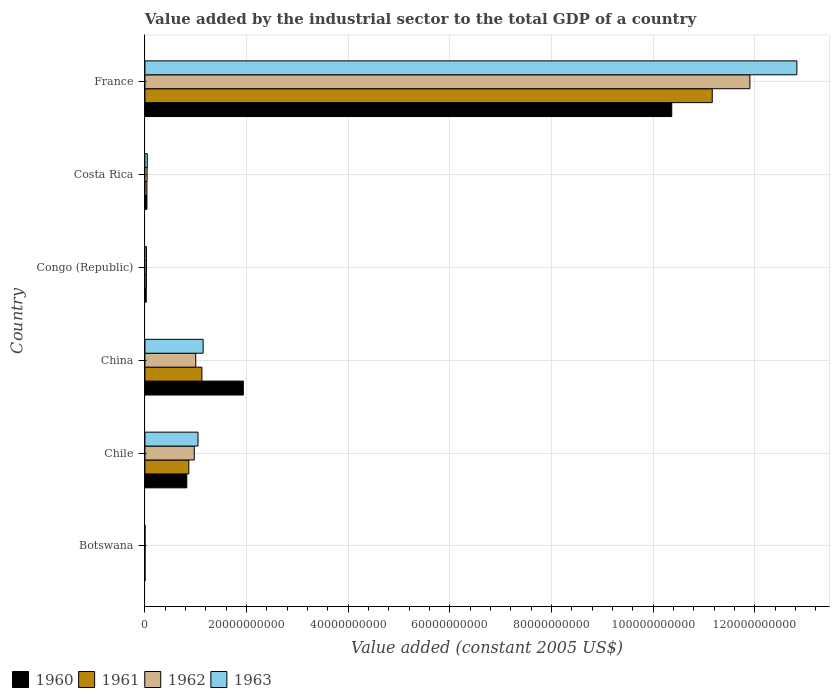How many different coloured bars are there?
Ensure brevity in your answer.  4. Are the number of bars per tick equal to the number of legend labels?
Make the answer very short. Yes. How many bars are there on the 5th tick from the top?
Make the answer very short. 4. How many bars are there on the 5th tick from the bottom?
Give a very brief answer. 4. In how many cases, is the number of bars for a given country not equal to the number of legend labels?
Your answer should be very brief. 0. What is the value added by the industrial sector in 1960 in Costa Rica?
Offer a terse response. 3.98e+08. Across all countries, what is the maximum value added by the industrial sector in 1962?
Provide a succinct answer. 1.19e+11. Across all countries, what is the minimum value added by the industrial sector in 1962?
Your answer should be very brief. 1.98e+07. In which country was the value added by the industrial sector in 1960 minimum?
Make the answer very short. Botswana. What is the total value added by the industrial sector in 1960 in the graph?
Make the answer very short. 1.32e+11. What is the difference between the value added by the industrial sector in 1960 in Congo (Republic) and that in France?
Make the answer very short. -1.03e+11. What is the difference between the value added by the industrial sector in 1961 in Botswana and the value added by the industrial sector in 1963 in China?
Your answer should be very brief. -1.14e+1. What is the average value added by the industrial sector in 1963 per country?
Make the answer very short. 2.52e+1. What is the difference between the value added by the industrial sector in 1962 and value added by the industrial sector in 1960 in Chile?
Your response must be concise. 1.47e+09. What is the ratio of the value added by the industrial sector in 1961 in Chile to that in France?
Give a very brief answer. 0.08. Is the value added by the industrial sector in 1961 in Costa Rica less than that in France?
Ensure brevity in your answer.  Yes. What is the difference between the highest and the second highest value added by the industrial sector in 1961?
Your answer should be very brief. 1.00e+11. What is the difference between the highest and the lowest value added by the industrial sector in 1962?
Ensure brevity in your answer.  1.19e+11. In how many countries, is the value added by the industrial sector in 1960 greater than the average value added by the industrial sector in 1960 taken over all countries?
Your answer should be compact. 1. Is the sum of the value added by the industrial sector in 1963 in Congo (Republic) and France greater than the maximum value added by the industrial sector in 1961 across all countries?
Your response must be concise. Yes. Is it the case that in every country, the sum of the value added by the industrial sector in 1961 and value added by the industrial sector in 1963 is greater than the sum of value added by the industrial sector in 1960 and value added by the industrial sector in 1962?
Offer a very short reply. No. Is it the case that in every country, the sum of the value added by the industrial sector in 1960 and value added by the industrial sector in 1962 is greater than the value added by the industrial sector in 1963?
Your answer should be compact. Yes. Are the values on the major ticks of X-axis written in scientific E-notation?
Offer a terse response. No. How many legend labels are there?
Your answer should be compact. 4. How are the legend labels stacked?
Ensure brevity in your answer.  Horizontal. What is the title of the graph?
Keep it short and to the point. Value added by the industrial sector to the total GDP of a country. What is the label or title of the X-axis?
Provide a succinct answer. Value added (constant 2005 US$). What is the label or title of the Y-axis?
Offer a terse response. Country. What is the Value added (constant 2005 US$) of 1960 in Botswana?
Your answer should be compact. 1.96e+07. What is the Value added (constant 2005 US$) of 1961 in Botswana?
Ensure brevity in your answer.  1.92e+07. What is the Value added (constant 2005 US$) in 1962 in Botswana?
Make the answer very short. 1.98e+07. What is the Value added (constant 2005 US$) in 1963 in Botswana?
Keep it short and to the point. 1.83e+07. What is the Value added (constant 2005 US$) of 1960 in Chile?
Provide a short and direct response. 8.24e+09. What is the Value added (constant 2005 US$) in 1961 in Chile?
Provide a succinct answer. 8.64e+09. What is the Value added (constant 2005 US$) in 1962 in Chile?
Make the answer very short. 9.71e+09. What is the Value added (constant 2005 US$) of 1963 in Chile?
Make the answer very short. 1.04e+1. What is the Value added (constant 2005 US$) in 1960 in China?
Give a very brief answer. 1.94e+1. What is the Value added (constant 2005 US$) in 1961 in China?
Offer a terse response. 1.12e+1. What is the Value added (constant 2005 US$) of 1962 in China?
Give a very brief answer. 1.00e+1. What is the Value added (constant 2005 US$) in 1963 in China?
Your answer should be compact. 1.15e+1. What is the Value added (constant 2005 US$) of 1960 in Congo (Republic)?
Provide a short and direct response. 2.61e+08. What is the Value added (constant 2005 US$) of 1961 in Congo (Republic)?
Your response must be concise. 2.98e+08. What is the Value added (constant 2005 US$) in 1962 in Congo (Republic)?
Give a very brief answer. 3.12e+08. What is the Value added (constant 2005 US$) of 1963 in Congo (Republic)?
Provide a succinct answer. 3.00e+08. What is the Value added (constant 2005 US$) of 1960 in Costa Rica?
Give a very brief answer. 3.98e+08. What is the Value added (constant 2005 US$) in 1961 in Costa Rica?
Your response must be concise. 3.94e+08. What is the Value added (constant 2005 US$) in 1962 in Costa Rica?
Provide a short and direct response. 4.27e+08. What is the Value added (constant 2005 US$) in 1963 in Costa Rica?
Ensure brevity in your answer.  4.68e+08. What is the Value added (constant 2005 US$) of 1960 in France?
Offer a terse response. 1.04e+11. What is the Value added (constant 2005 US$) in 1961 in France?
Offer a terse response. 1.12e+11. What is the Value added (constant 2005 US$) in 1962 in France?
Ensure brevity in your answer.  1.19e+11. What is the Value added (constant 2005 US$) of 1963 in France?
Provide a succinct answer. 1.28e+11. Across all countries, what is the maximum Value added (constant 2005 US$) in 1960?
Offer a terse response. 1.04e+11. Across all countries, what is the maximum Value added (constant 2005 US$) of 1961?
Your response must be concise. 1.12e+11. Across all countries, what is the maximum Value added (constant 2005 US$) of 1962?
Your answer should be very brief. 1.19e+11. Across all countries, what is the maximum Value added (constant 2005 US$) in 1963?
Keep it short and to the point. 1.28e+11. Across all countries, what is the minimum Value added (constant 2005 US$) of 1960?
Your response must be concise. 1.96e+07. Across all countries, what is the minimum Value added (constant 2005 US$) in 1961?
Ensure brevity in your answer.  1.92e+07. Across all countries, what is the minimum Value added (constant 2005 US$) of 1962?
Your response must be concise. 1.98e+07. Across all countries, what is the minimum Value added (constant 2005 US$) of 1963?
Keep it short and to the point. 1.83e+07. What is the total Value added (constant 2005 US$) in 1960 in the graph?
Ensure brevity in your answer.  1.32e+11. What is the total Value added (constant 2005 US$) of 1961 in the graph?
Your answer should be very brief. 1.32e+11. What is the total Value added (constant 2005 US$) in 1962 in the graph?
Keep it short and to the point. 1.40e+11. What is the total Value added (constant 2005 US$) in 1963 in the graph?
Provide a succinct answer. 1.51e+11. What is the difference between the Value added (constant 2005 US$) of 1960 in Botswana and that in Chile?
Provide a short and direct response. -8.22e+09. What is the difference between the Value added (constant 2005 US$) of 1961 in Botswana and that in Chile?
Keep it short and to the point. -8.62e+09. What is the difference between the Value added (constant 2005 US$) of 1962 in Botswana and that in Chile?
Provide a succinct answer. -9.69e+09. What is the difference between the Value added (constant 2005 US$) of 1963 in Botswana and that in Chile?
Your response must be concise. -1.04e+1. What is the difference between the Value added (constant 2005 US$) in 1960 in Botswana and that in China?
Your response must be concise. -1.93e+1. What is the difference between the Value added (constant 2005 US$) in 1961 in Botswana and that in China?
Your response must be concise. -1.12e+1. What is the difference between the Value added (constant 2005 US$) in 1962 in Botswana and that in China?
Make the answer very short. -9.98e+09. What is the difference between the Value added (constant 2005 US$) in 1963 in Botswana and that in China?
Offer a very short reply. -1.14e+1. What is the difference between the Value added (constant 2005 US$) in 1960 in Botswana and that in Congo (Republic)?
Ensure brevity in your answer.  -2.42e+08. What is the difference between the Value added (constant 2005 US$) of 1961 in Botswana and that in Congo (Republic)?
Your answer should be compact. -2.78e+08. What is the difference between the Value added (constant 2005 US$) in 1962 in Botswana and that in Congo (Republic)?
Provide a short and direct response. -2.93e+08. What is the difference between the Value added (constant 2005 US$) in 1963 in Botswana and that in Congo (Republic)?
Your answer should be compact. -2.81e+08. What is the difference between the Value added (constant 2005 US$) of 1960 in Botswana and that in Costa Rica?
Your answer should be very brief. -3.78e+08. What is the difference between the Value added (constant 2005 US$) in 1961 in Botswana and that in Costa Rica?
Keep it short and to the point. -3.74e+08. What is the difference between the Value added (constant 2005 US$) in 1962 in Botswana and that in Costa Rica?
Make the answer very short. -4.07e+08. What is the difference between the Value added (constant 2005 US$) in 1963 in Botswana and that in Costa Rica?
Offer a terse response. -4.50e+08. What is the difference between the Value added (constant 2005 US$) of 1960 in Botswana and that in France?
Provide a short and direct response. -1.04e+11. What is the difference between the Value added (constant 2005 US$) in 1961 in Botswana and that in France?
Your response must be concise. -1.12e+11. What is the difference between the Value added (constant 2005 US$) in 1962 in Botswana and that in France?
Ensure brevity in your answer.  -1.19e+11. What is the difference between the Value added (constant 2005 US$) in 1963 in Botswana and that in France?
Ensure brevity in your answer.  -1.28e+11. What is the difference between the Value added (constant 2005 US$) of 1960 in Chile and that in China?
Your answer should be very brief. -1.11e+1. What is the difference between the Value added (constant 2005 US$) in 1961 in Chile and that in China?
Offer a very short reply. -2.57e+09. What is the difference between the Value added (constant 2005 US$) in 1962 in Chile and that in China?
Ensure brevity in your answer.  -2.92e+08. What is the difference between the Value added (constant 2005 US$) of 1963 in Chile and that in China?
Offer a very short reply. -1.01e+09. What is the difference between the Value added (constant 2005 US$) in 1960 in Chile and that in Congo (Republic)?
Your answer should be very brief. 7.98e+09. What is the difference between the Value added (constant 2005 US$) of 1961 in Chile and that in Congo (Republic)?
Make the answer very short. 8.34e+09. What is the difference between the Value added (constant 2005 US$) in 1962 in Chile and that in Congo (Republic)?
Offer a terse response. 9.40e+09. What is the difference between the Value added (constant 2005 US$) in 1963 in Chile and that in Congo (Republic)?
Your answer should be very brief. 1.01e+1. What is the difference between the Value added (constant 2005 US$) of 1960 in Chile and that in Costa Rica?
Offer a terse response. 7.84e+09. What is the difference between the Value added (constant 2005 US$) of 1961 in Chile and that in Costa Rica?
Offer a very short reply. 8.25e+09. What is the difference between the Value added (constant 2005 US$) in 1962 in Chile and that in Costa Rica?
Offer a very short reply. 9.28e+09. What is the difference between the Value added (constant 2005 US$) in 1963 in Chile and that in Costa Rica?
Your answer should be compact. 9.98e+09. What is the difference between the Value added (constant 2005 US$) of 1960 in Chile and that in France?
Provide a short and direct response. -9.54e+1. What is the difference between the Value added (constant 2005 US$) in 1961 in Chile and that in France?
Your answer should be compact. -1.03e+11. What is the difference between the Value added (constant 2005 US$) of 1962 in Chile and that in France?
Your answer should be very brief. -1.09e+11. What is the difference between the Value added (constant 2005 US$) of 1963 in Chile and that in France?
Your response must be concise. -1.18e+11. What is the difference between the Value added (constant 2005 US$) of 1960 in China and that in Congo (Republic)?
Your answer should be compact. 1.91e+1. What is the difference between the Value added (constant 2005 US$) in 1961 in China and that in Congo (Republic)?
Provide a succinct answer. 1.09e+1. What is the difference between the Value added (constant 2005 US$) of 1962 in China and that in Congo (Republic)?
Provide a short and direct response. 9.69e+09. What is the difference between the Value added (constant 2005 US$) of 1963 in China and that in Congo (Republic)?
Provide a succinct answer. 1.12e+1. What is the difference between the Value added (constant 2005 US$) in 1960 in China and that in Costa Rica?
Make the answer very short. 1.90e+1. What is the difference between the Value added (constant 2005 US$) of 1961 in China and that in Costa Rica?
Your response must be concise. 1.08e+1. What is the difference between the Value added (constant 2005 US$) of 1962 in China and that in Costa Rica?
Your answer should be very brief. 9.58e+09. What is the difference between the Value added (constant 2005 US$) of 1963 in China and that in Costa Rica?
Ensure brevity in your answer.  1.10e+1. What is the difference between the Value added (constant 2005 US$) in 1960 in China and that in France?
Your answer should be compact. -8.43e+1. What is the difference between the Value added (constant 2005 US$) in 1961 in China and that in France?
Keep it short and to the point. -1.00e+11. What is the difference between the Value added (constant 2005 US$) in 1962 in China and that in France?
Your response must be concise. -1.09e+11. What is the difference between the Value added (constant 2005 US$) in 1963 in China and that in France?
Keep it short and to the point. -1.17e+11. What is the difference between the Value added (constant 2005 US$) of 1960 in Congo (Republic) and that in Costa Rica?
Offer a very short reply. -1.36e+08. What is the difference between the Value added (constant 2005 US$) of 1961 in Congo (Republic) and that in Costa Rica?
Offer a very short reply. -9.59e+07. What is the difference between the Value added (constant 2005 US$) of 1962 in Congo (Republic) and that in Costa Rica?
Keep it short and to the point. -1.14e+08. What is the difference between the Value added (constant 2005 US$) in 1963 in Congo (Republic) and that in Costa Rica?
Your answer should be compact. -1.68e+08. What is the difference between the Value added (constant 2005 US$) in 1960 in Congo (Republic) and that in France?
Provide a short and direct response. -1.03e+11. What is the difference between the Value added (constant 2005 US$) in 1961 in Congo (Republic) and that in France?
Offer a very short reply. -1.11e+11. What is the difference between the Value added (constant 2005 US$) in 1962 in Congo (Republic) and that in France?
Your answer should be very brief. -1.19e+11. What is the difference between the Value added (constant 2005 US$) of 1963 in Congo (Republic) and that in France?
Your answer should be very brief. -1.28e+11. What is the difference between the Value added (constant 2005 US$) in 1960 in Costa Rica and that in France?
Your answer should be compact. -1.03e+11. What is the difference between the Value added (constant 2005 US$) of 1961 in Costa Rica and that in France?
Give a very brief answer. -1.11e+11. What is the difference between the Value added (constant 2005 US$) of 1962 in Costa Rica and that in France?
Keep it short and to the point. -1.19e+11. What is the difference between the Value added (constant 2005 US$) of 1963 in Costa Rica and that in France?
Make the answer very short. -1.28e+11. What is the difference between the Value added (constant 2005 US$) in 1960 in Botswana and the Value added (constant 2005 US$) in 1961 in Chile?
Keep it short and to the point. -8.62e+09. What is the difference between the Value added (constant 2005 US$) of 1960 in Botswana and the Value added (constant 2005 US$) of 1962 in Chile?
Ensure brevity in your answer.  -9.69e+09. What is the difference between the Value added (constant 2005 US$) in 1960 in Botswana and the Value added (constant 2005 US$) in 1963 in Chile?
Keep it short and to the point. -1.04e+1. What is the difference between the Value added (constant 2005 US$) of 1961 in Botswana and the Value added (constant 2005 US$) of 1962 in Chile?
Ensure brevity in your answer.  -9.69e+09. What is the difference between the Value added (constant 2005 US$) in 1961 in Botswana and the Value added (constant 2005 US$) in 1963 in Chile?
Offer a very short reply. -1.04e+1. What is the difference between the Value added (constant 2005 US$) in 1962 in Botswana and the Value added (constant 2005 US$) in 1963 in Chile?
Give a very brief answer. -1.04e+1. What is the difference between the Value added (constant 2005 US$) of 1960 in Botswana and the Value added (constant 2005 US$) of 1961 in China?
Give a very brief answer. -1.12e+1. What is the difference between the Value added (constant 2005 US$) of 1960 in Botswana and the Value added (constant 2005 US$) of 1962 in China?
Your response must be concise. -9.98e+09. What is the difference between the Value added (constant 2005 US$) in 1960 in Botswana and the Value added (constant 2005 US$) in 1963 in China?
Offer a very short reply. -1.14e+1. What is the difference between the Value added (constant 2005 US$) in 1961 in Botswana and the Value added (constant 2005 US$) in 1962 in China?
Keep it short and to the point. -9.98e+09. What is the difference between the Value added (constant 2005 US$) of 1961 in Botswana and the Value added (constant 2005 US$) of 1963 in China?
Ensure brevity in your answer.  -1.14e+1. What is the difference between the Value added (constant 2005 US$) of 1962 in Botswana and the Value added (constant 2005 US$) of 1963 in China?
Your answer should be very brief. -1.14e+1. What is the difference between the Value added (constant 2005 US$) of 1960 in Botswana and the Value added (constant 2005 US$) of 1961 in Congo (Republic)?
Make the answer very short. -2.78e+08. What is the difference between the Value added (constant 2005 US$) in 1960 in Botswana and the Value added (constant 2005 US$) in 1962 in Congo (Republic)?
Provide a short and direct response. -2.93e+08. What is the difference between the Value added (constant 2005 US$) of 1960 in Botswana and the Value added (constant 2005 US$) of 1963 in Congo (Republic)?
Keep it short and to the point. -2.80e+08. What is the difference between the Value added (constant 2005 US$) in 1961 in Botswana and the Value added (constant 2005 US$) in 1962 in Congo (Republic)?
Your answer should be compact. -2.93e+08. What is the difference between the Value added (constant 2005 US$) in 1961 in Botswana and the Value added (constant 2005 US$) in 1963 in Congo (Republic)?
Your response must be concise. -2.81e+08. What is the difference between the Value added (constant 2005 US$) of 1962 in Botswana and the Value added (constant 2005 US$) of 1963 in Congo (Republic)?
Your answer should be compact. -2.80e+08. What is the difference between the Value added (constant 2005 US$) of 1960 in Botswana and the Value added (constant 2005 US$) of 1961 in Costa Rica?
Your answer should be compact. -3.74e+08. What is the difference between the Value added (constant 2005 US$) of 1960 in Botswana and the Value added (constant 2005 US$) of 1962 in Costa Rica?
Provide a short and direct response. -4.07e+08. What is the difference between the Value added (constant 2005 US$) of 1960 in Botswana and the Value added (constant 2005 US$) of 1963 in Costa Rica?
Make the answer very short. -4.48e+08. What is the difference between the Value added (constant 2005 US$) of 1961 in Botswana and the Value added (constant 2005 US$) of 1962 in Costa Rica?
Give a very brief answer. -4.08e+08. What is the difference between the Value added (constant 2005 US$) in 1961 in Botswana and the Value added (constant 2005 US$) in 1963 in Costa Rica?
Your response must be concise. -4.49e+08. What is the difference between the Value added (constant 2005 US$) of 1962 in Botswana and the Value added (constant 2005 US$) of 1963 in Costa Rica?
Provide a succinct answer. -4.48e+08. What is the difference between the Value added (constant 2005 US$) of 1960 in Botswana and the Value added (constant 2005 US$) of 1961 in France?
Keep it short and to the point. -1.12e+11. What is the difference between the Value added (constant 2005 US$) of 1960 in Botswana and the Value added (constant 2005 US$) of 1962 in France?
Provide a succinct answer. -1.19e+11. What is the difference between the Value added (constant 2005 US$) in 1960 in Botswana and the Value added (constant 2005 US$) in 1963 in France?
Provide a short and direct response. -1.28e+11. What is the difference between the Value added (constant 2005 US$) in 1961 in Botswana and the Value added (constant 2005 US$) in 1962 in France?
Provide a succinct answer. -1.19e+11. What is the difference between the Value added (constant 2005 US$) in 1961 in Botswana and the Value added (constant 2005 US$) in 1963 in France?
Give a very brief answer. -1.28e+11. What is the difference between the Value added (constant 2005 US$) in 1962 in Botswana and the Value added (constant 2005 US$) in 1963 in France?
Your response must be concise. -1.28e+11. What is the difference between the Value added (constant 2005 US$) of 1960 in Chile and the Value added (constant 2005 US$) of 1961 in China?
Your response must be concise. -2.97e+09. What is the difference between the Value added (constant 2005 US$) in 1960 in Chile and the Value added (constant 2005 US$) in 1962 in China?
Keep it short and to the point. -1.76e+09. What is the difference between the Value added (constant 2005 US$) in 1960 in Chile and the Value added (constant 2005 US$) in 1963 in China?
Your response must be concise. -3.21e+09. What is the difference between the Value added (constant 2005 US$) in 1961 in Chile and the Value added (constant 2005 US$) in 1962 in China?
Keep it short and to the point. -1.36e+09. What is the difference between the Value added (constant 2005 US$) of 1961 in Chile and the Value added (constant 2005 US$) of 1963 in China?
Ensure brevity in your answer.  -2.81e+09. What is the difference between the Value added (constant 2005 US$) in 1962 in Chile and the Value added (constant 2005 US$) in 1963 in China?
Your answer should be compact. -1.74e+09. What is the difference between the Value added (constant 2005 US$) in 1960 in Chile and the Value added (constant 2005 US$) in 1961 in Congo (Republic)?
Offer a very short reply. 7.94e+09. What is the difference between the Value added (constant 2005 US$) in 1960 in Chile and the Value added (constant 2005 US$) in 1962 in Congo (Republic)?
Make the answer very short. 7.93e+09. What is the difference between the Value added (constant 2005 US$) in 1960 in Chile and the Value added (constant 2005 US$) in 1963 in Congo (Republic)?
Offer a very short reply. 7.94e+09. What is the difference between the Value added (constant 2005 US$) of 1961 in Chile and the Value added (constant 2005 US$) of 1962 in Congo (Republic)?
Your answer should be very brief. 8.33e+09. What is the difference between the Value added (constant 2005 US$) of 1961 in Chile and the Value added (constant 2005 US$) of 1963 in Congo (Republic)?
Provide a succinct answer. 8.34e+09. What is the difference between the Value added (constant 2005 US$) of 1962 in Chile and the Value added (constant 2005 US$) of 1963 in Congo (Republic)?
Your answer should be very brief. 9.41e+09. What is the difference between the Value added (constant 2005 US$) of 1960 in Chile and the Value added (constant 2005 US$) of 1961 in Costa Rica?
Ensure brevity in your answer.  7.85e+09. What is the difference between the Value added (constant 2005 US$) of 1960 in Chile and the Value added (constant 2005 US$) of 1962 in Costa Rica?
Provide a short and direct response. 7.81e+09. What is the difference between the Value added (constant 2005 US$) of 1960 in Chile and the Value added (constant 2005 US$) of 1963 in Costa Rica?
Your response must be concise. 7.77e+09. What is the difference between the Value added (constant 2005 US$) of 1961 in Chile and the Value added (constant 2005 US$) of 1962 in Costa Rica?
Provide a succinct answer. 8.21e+09. What is the difference between the Value added (constant 2005 US$) of 1961 in Chile and the Value added (constant 2005 US$) of 1963 in Costa Rica?
Give a very brief answer. 8.17e+09. What is the difference between the Value added (constant 2005 US$) of 1962 in Chile and the Value added (constant 2005 US$) of 1963 in Costa Rica?
Your answer should be very brief. 9.24e+09. What is the difference between the Value added (constant 2005 US$) in 1960 in Chile and the Value added (constant 2005 US$) in 1961 in France?
Offer a terse response. -1.03e+11. What is the difference between the Value added (constant 2005 US$) in 1960 in Chile and the Value added (constant 2005 US$) in 1962 in France?
Offer a very short reply. -1.11e+11. What is the difference between the Value added (constant 2005 US$) of 1960 in Chile and the Value added (constant 2005 US$) of 1963 in France?
Make the answer very short. -1.20e+11. What is the difference between the Value added (constant 2005 US$) in 1961 in Chile and the Value added (constant 2005 US$) in 1962 in France?
Offer a very short reply. -1.10e+11. What is the difference between the Value added (constant 2005 US$) of 1961 in Chile and the Value added (constant 2005 US$) of 1963 in France?
Ensure brevity in your answer.  -1.20e+11. What is the difference between the Value added (constant 2005 US$) of 1962 in Chile and the Value added (constant 2005 US$) of 1963 in France?
Ensure brevity in your answer.  -1.19e+11. What is the difference between the Value added (constant 2005 US$) of 1960 in China and the Value added (constant 2005 US$) of 1961 in Congo (Republic)?
Provide a succinct answer. 1.91e+1. What is the difference between the Value added (constant 2005 US$) in 1960 in China and the Value added (constant 2005 US$) in 1962 in Congo (Republic)?
Keep it short and to the point. 1.91e+1. What is the difference between the Value added (constant 2005 US$) of 1960 in China and the Value added (constant 2005 US$) of 1963 in Congo (Republic)?
Keep it short and to the point. 1.91e+1. What is the difference between the Value added (constant 2005 US$) in 1961 in China and the Value added (constant 2005 US$) in 1962 in Congo (Republic)?
Your answer should be very brief. 1.09e+1. What is the difference between the Value added (constant 2005 US$) of 1961 in China and the Value added (constant 2005 US$) of 1963 in Congo (Republic)?
Give a very brief answer. 1.09e+1. What is the difference between the Value added (constant 2005 US$) of 1962 in China and the Value added (constant 2005 US$) of 1963 in Congo (Republic)?
Provide a succinct answer. 9.70e+09. What is the difference between the Value added (constant 2005 US$) in 1960 in China and the Value added (constant 2005 US$) in 1961 in Costa Rica?
Your answer should be very brief. 1.90e+1. What is the difference between the Value added (constant 2005 US$) in 1960 in China and the Value added (constant 2005 US$) in 1962 in Costa Rica?
Ensure brevity in your answer.  1.89e+1. What is the difference between the Value added (constant 2005 US$) in 1960 in China and the Value added (constant 2005 US$) in 1963 in Costa Rica?
Your answer should be very brief. 1.89e+1. What is the difference between the Value added (constant 2005 US$) in 1961 in China and the Value added (constant 2005 US$) in 1962 in Costa Rica?
Offer a terse response. 1.08e+1. What is the difference between the Value added (constant 2005 US$) in 1961 in China and the Value added (constant 2005 US$) in 1963 in Costa Rica?
Ensure brevity in your answer.  1.07e+1. What is the difference between the Value added (constant 2005 US$) in 1962 in China and the Value added (constant 2005 US$) in 1963 in Costa Rica?
Ensure brevity in your answer.  9.53e+09. What is the difference between the Value added (constant 2005 US$) of 1960 in China and the Value added (constant 2005 US$) of 1961 in France?
Ensure brevity in your answer.  -9.23e+1. What is the difference between the Value added (constant 2005 US$) of 1960 in China and the Value added (constant 2005 US$) of 1962 in France?
Provide a short and direct response. -9.97e+1. What is the difference between the Value added (constant 2005 US$) of 1960 in China and the Value added (constant 2005 US$) of 1963 in France?
Provide a succinct answer. -1.09e+11. What is the difference between the Value added (constant 2005 US$) in 1961 in China and the Value added (constant 2005 US$) in 1962 in France?
Offer a terse response. -1.08e+11. What is the difference between the Value added (constant 2005 US$) in 1961 in China and the Value added (constant 2005 US$) in 1963 in France?
Provide a short and direct response. -1.17e+11. What is the difference between the Value added (constant 2005 US$) in 1962 in China and the Value added (constant 2005 US$) in 1963 in France?
Make the answer very short. -1.18e+11. What is the difference between the Value added (constant 2005 US$) of 1960 in Congo (Republic) and the Value added (constant 2005 US$) of 1961 in Costa Rica?
Ensure brevity in your answer.  -1.32e+08. What is the difference between the Value added (constant 2005 US$) in 1960 in Congo (Republic) and the Value added (constant 2005 US$) in 1962 in Costa Rica?
Provide a succinct answer. -1.65e+08. What is the difference between the Value added (constant 2005 US$) in 1960 in Congo (Republic) and the Value added (constant 2005 US$) in 1963 in Costa Rica?
Make the answer very short. -2.07e+08. What is the difference between the Value added (constant 2005 US$) of 1961 in Congo (Republic) and the Value added (constant 2005 US$) of 1962 in Costa Rica?
Your answer should be compact. -1.29e+08. What is the difference between the Value added (constant 2005 US$) of 1961 in Congo (Republic) and the Value added (constant 2005 US$) of 1963 in Costa Rica?
Offer a terse response. -1.70e+08. What is the difference between the Value added (constant 2005 US$) of 1962 in Congo (Republic) and the Value added (constant 2005 US$) of 1963 in Costa Rica?
Ensure brevity in your answer.  -1.56e+08. What is the difference between the Value added (constant 2005 US$) in 1960 in Congo (Republic) and the Value added (constant 2005 US$) in 1961 in France?
Make the answer very short. -1.11e+11. What is the difference between the Value added (constant 2005 US$) of 1960 in Congo (Republic) and the Value added (constant 2005 US$) of 1962 in France?
Your answer should be very brief. -1.19e+11. What is the difference between the Value added (constant 2005 US$) of 1960 in Congo (Republic) and the Value added (constant 2005 US$) of 1963 in France?
Offer a very short reply. -1.28e+11. What is the difference between the Value added (constant 2005 US$) in 1961 in Congo (Republic) and the Value added (constant 2005 US$) in 1962 in France?
Offer a terse response. -1.19e+11. What is the difference between the Value added (constant 2005 US$) of 1961 in Congo (Republic) and the Value added (constant 2005 US$) of 1963 in France?
Your response must be concise. -1.28e+11. What is the difference between the Value added (constant 2005 US$) in 1962 in Congo (Republic) and the Value added (constant 2005 US$) in 1963 in France?
Your response must be concise. -1.28e+11. What is the difference between the Value added (constant 2005 US$) of 1960 in Costa Rica and the Value added (constant 2005 US$) of 1961 in France?
Offer a terse response. -1.11e+11. What is the difference between the Value added (constant 2005 US$) of 1960 in Costa Rica and the Value added (constant 2005 US$) of 1962 in France?
Offer a very short reply. -1.19e+11. What is the difference between the Value added (constant 2005 US$) in 1960 in Costa Rica and the Value added (constant 2005 US$) in 1963 in France?
Your answer should be very brief. -1.28e+11. What is the difference between the Value added (constant 2005 US$) of 1961 in Costa Rica and the Value added (constant 2005 US$) of 1962 in France?
Your response must be concise. -1.19e+11. What is the difference between the Value added (constant 2005 US$) of 1961 in Costa Rica and the Value added (constant 2005 US$) of 1963 in France?
Ensure brevity in your answer.  -1.28e+11. What is the difference between the Value added (constant 2005 US$) of 1962 in Costa Rica and the Value added (constant 2005 US$) of 1963 in France?
Make the answer very short. -1.28e+11. What is the average Value added (constant 2005 US$) in 1960 per country?
Your answer should be very brief. 2.20e+1. What is the average Value added (constant 2005 US$) of 1961 per country?
Ensure brevity in your answer.  2.20e+1. What is the average Value added (constant 2005 US$) in 1962 per country?
Make the answer very short. 2.33e+1. What is the average Value added (constant 2005 US$) of 1963 per country?
Ensure brevity in your answer.  2.52e+1. What is the difference between the Value added (constant 2005 US$) of 1960 and Value added (constant 2005 US$) of 1961 in Botswana?
Make the answer very short. 4.24e+05. What is the difference between the Value added (constant 2005 US$) in 1960 and Value added (constant 2005 US$) in 1962 in Botswana?
Your answer should be very brief. -2.12e+05. What is the difference between the Value added (constant 2005 US$) in 1960 and Value added (constant 2005 US$) in 1963 in Botswana?
Give a very brief answer. 1.27e+06. What is the difference between the Value added (constant 2005 US$) in 1961 and Value added (constant 2005 US$) in 1962 in Botswana?
Keep it short and to the point. -6.36e+05. What is the difference between the Value added (constant 2005 US$) in 1961 and Value added (constant 2005 US$) in 1963 in Botswana?
Keep it short and to the point. 8.48e+05. What is the difference between the Value added (constant 2005 US$) in 1962 and Value added (constant 2005 US$) in 1963 in Botswana?
Your response must be concise. 1.48e+06. What is the difference between the Value added (constant 2005 US$) in 1960 and Value added (constant 2005 US$) in 1961 in Chile?
Your response must be concise. -4.01e+08. What is the difference between the Value added (constant 2005 US$) in 1960 and Value added (constant 2005 US$) in 1962 in Chile?
Give a very brief answer. -1.47e+09. What is the difference between the Value added (constant 2005 US$) in 1960 and Value added (constant 2005 US$) in 1963 in Chile?
Your response must be concise. -2.21e+09. What is the difference between the Value added (constant 2005 US$) in 1961 and Value added (constant 2005 US$) in 1962 in Chile?
Your answer should be very brief. -1.07e+09. What is the difference between the Value added (constant 2005 US$) in 1961 and Value added (constant 2005 US$) in 1963 in Chile?
Give a very brief answer. -1.81e+09. What is the difference between the Value added (constant 2005 US$) of 1962 and Value added (constant 2005 US$) of 1963 in Chile?
Offer a terse response. -7.37e+08. What is the difference between the Value added (constant 2005 US$) in 1960 and Value added (constant 2005 US$) in 1961 in China?
Ensure brevity in your answer.  8.15e+09. What is the difference between the Value added (constant 2005 US$) of 1960 and Value added (constant 2005 US$) of 1962 in China?
Give a very brief answer. 9.36e+09. What is the difference between the Value added (constant 2005 US$) of 1960 and Value added (constant 2005 US$) of 1963 in China?
Your answer should be compact. 7.91e+09. What is the difference between the Value added (constant 2005 US$) in 1961 and Value added (constant 2005 US$) in 1962 in China?
Your answer should be very brief. 1.21e+09. What is the difference between the Value added (constant 2005 US$) of 1961 and Value added (constant 2005 US$) of 1963 in China?
Offer a very short reply. -2.39e+08. What is the difference between the Value added (constant 2005 US$) of 1962 and Value added (constant 2005 US$) of 1963 in China?
Give a very brief answer. -1.45e+09. What is the difference between the Value added (constant 2005 US$) in 1960 and Value added (constant 2005 US$) in 1961 in Congo (Republic)?
Give a very brief answer. -3.63e+07. What is the difference between the Value added (constant 2005 US$) in 1960 and Value added (constant 2005 US$) in 1962 in Congo (Republic)?
Offer a very short reply. -5.10e+07. What is the difference between the Value added (constant 2005 US$) of 1960 and Value added (constant 2005 US$) of 1963 in Congo (Republic)?
Keep it short and to the point. -3.84e+07. What is the difference between the Value added (constant 2005 US$) of 1961 and Value added (constant 2005 US$) of 1962 in Congo (Republic)?
Offer a terse response. -1.47e+07. What is the difference between the Value added (constant 2005 US$) in 1961 and Value added (constant 2005 US$) in 1963 in Congo (Republic)?
Make the answer very short. -2.10e+06. What is the difference between the Value added (constant 2005 US$) in 1962 and Value added (constant 2005 US$) in 1963 in Congo (Republic)?
Ensure brevity in your answer.  1.26e+07. What is the difference between the Value added (constant 2005 US$) of 1960 and Value added (constant 2005 US$) of 1961 in Costa Rica?
Ensure brevity in your answer.  4.19e+06. What is the difference between the Value added (constant 2005 US$) in 1960 and Value added (constant 2005 US$) in 1962 in Costa Rica?
Your response must be concise. -2.91e+07. What is the difference between the Value added (constant 2005 US$) in 1960 and Value added (constant 2005 US$) in 1963 in Costa Rica?
Ensure brevity in your answer.  -7.01e+07. What is the difference between the Value added (constant 2005 US$) in 1961 and Value added (constant 2005 US$) in 1962 in Costa Rica?
Offer a terse response. -3.32e+07. What is the difference between the Value added (constant 2005 US$) of 1961 and Value added (constant 2005 US$) of 1963 in Costa Rica?
Give a very brief answer. -7.43e+07. What is the difference between the Value added (constant 2005 US$) of 1962 and Value added (constant 2005 US$) of 1963 in Costa Rica?
Provide a succinct answer. -4.11e+07. What is the difference between the Value added (constant 2005 US$) of 1960 and Value added (constant 2005 US$) of 1961 in France?
Make the answer very short. -7.97e+09. What is the difference between the Value added (constant 2005 US$) in 1960 and Value added (constant 2005 US$) in 1962 in France?
Keep it short and to the point. -1.54e+1. What is the difference between the Value added (constant 2005 US$) of 1960 and Value added (constant 2005 US$) of 1963 in France?
Give a very brief answer. -2.46e+1. What is the difference between the Value added (constant 2005 US$) of 1961 and Value added (constant 2005 US$) of 1962 in France?
Offer a very short reply. -7.41e+09. What is the difference between the Value added (constant 2005 US$) in 1961 and Value added (constant 2005 US$) in 1963 in France?
Provide a succinct answer. -1.67e+1. What is the difference between the Value added (constant 2005 US$) in 1962 and Value added (constant 2005 US$) in 1963 in France?
Keep it short and to the point. -9.25e+09. What is the ratio of the Value added (constant 2005 US$) of 1960 in Botswana to that in Chile?
Provide a short and direct response. 0. What is the ratio of the Value added (constant 2005 US$) in 1961 in Botswana to that in Chile?
Give a very brief answer. 0. What is the ratio of the Value added (constant 2005 US$) of 1962 in Botswana to that in Chile?
Offer a very short reply. 0. What is the ratio of the Value added (constant 2005 US$) of 1963 in Botswana to that in Chile?
Your answer should be very brief. 0. What is the ratio of the Value added (constant 2005 US$) in 1961 in Botswana to that in China?
Offer a terse response. 0. What is the ratio of the Value added (constant 2005 US$) in 1962 in Botswana to that in China?
Ensure brevity in your answer.  0. What is the ratio of the Value added (constant 2005 US$) of 1963 in Botswana to that in China?
Keep it short and to the point. 0. What is the ratio of the Value added (constant 2005 US$) in 1960 in Botswana to that in Congo (Republic)?
Provide a short and direct response. 0.07. What is the ratio of the Value added (constant 2005 US$) of 1961 in Botswana to that in Congo (Republic)?
Give a very brief answer. 0.06. What is the ratio of the Value added (constant 2005 US$) of 1962 in Botswana to that in Congo (Republic)?
Provide a succinct answer. 0.06. What is the ratio of the Value added (constant 2005 US$) of 1963 in Botswana to that in Congo (Republic)?
Make the answer very short. 0.06. What is the ratio of the Value added (constant 2005 US$) of 1960 in Botswana to that in Costa Rica?
Offer a terse response. 0.05. What is the ratio of the Value added (constant 2005 US$) of 1961 in Botswana to that in Costa Rica?
Provide a succinct answer. 0.05. What is the ratio of the Value added (constant 2005 US$) in 1962 in Botswana to that in Costa Rica?
Give a very brief answer. 0.05. What is the ratio of the Value added (constant 2005 US$) in 1963 in Botswana to that in Costa Rica?
Give a very brief answer. 0.04. What is the ratio of the Value added (constant 2005 US$) in 1962 in Botswana to that in France?
Provide a succinct answer. 0. What is the ratio of the Value added (constant 2005 US$) of 1963 in Botswana to that in France?
Provide a succinct answer. 0. What is the ratio of the Value added (constant 2005 US$) of 1960 in Chile to that in China?
Ensure brevity in your answer.  0.43. What is the ratio of the Value added (constant 2005 US$) in 1961 in Chile to that in China?
Your answer should be compact. 0.77. What is the ratio of the Value added (constant 2005 US$) of 1962 in Chile to that in China?
Provide a succinct answer. 0.97. What is the ratio of the Value added (constant 2005 US$) in 1963 in Chile to that in China?
Your answer should be compact. 0.91. What is the ratio of the Value added (constant 2005 US$) of 1960 in Chile to that in Congo (Republic)?
Your answer should be compact. 31.52. What is the ratio of the Value added (constant 2005 US$) of 1961 in Chile to that in Congo (Republic)?
Provide a succinct answer. 29.03. What is the ratio of the Value added (constant 2005 US$) in 1962 in Chile to that in Congo (Republic)?
Your response must be concise. 31.09. What is the ratio of the Value added (constant 2005 US$) in 1963 in Chile to that in Congo (Republic)?
Offer a terse response. 34.85. What is the ratio of the Value added (constant 2005 US$) in 1960 in Chile to that in Costa Rica?
Offer a very short reply. 20.71. What is the ratio of the Value added (constant 2005 US$) in 1961 in Chile to that in Costa Rica?
Give a very brief answer. 21.95. What is the ratio of the Value added (constant 2005 US$) of 1962 in Chile to that in Costa Rica?
Offer a very short reply. 22.75. What is the ratio of the Value added (constant 2005 US$) in 1963 in Chile to that in Costa Rica?
Your answer should be very brief. 22.33. What is the ratio of the Value added (constant 2005 US$) in 1960 in Chile to that in France?
Provide a short and direct response. 0.08. What is the ratio of the Value added (constant 2005 US$) of 1961 in Chile to that in France?
Provide a short and direct response. 0.08. What is the ratio of the Value added (constant 2005 US$) in 1962 in Chile to that in France?
Offer a very short reply. 0.08. What is the ratio of the Value added (constant 2005 US$) of 1963 in Chile to that in France?
Offer a very short reply. 0.08. What is the ratio of the Value added (constant 2005 US$) in 1960 in China to that in Congo (Republic)?
Provide a succinct answer. 74.09. What is the ratio of the Value added (constant 2005 US$) of 1961 in China to that in Congo (Republic)?
Give a very brief answer. 37.67. What is the ratio of the Value added (constant 2005 US$) in 1962 in China to that in Congo (Republic)?
Your response must be concise. 32.02. What is the ratio of the Value added (constant 2005 US$) in 1963 in China to that in Congo (Republic)?
Your answer should be compact. 38.21. What is the ratio of the Value added (constant 2005 US$) in 1960 in China to that in Costa Rica?
Provide a succinct answer. 48.69. What is the ratio of the Value added (constant 2005 US$) of 1961 in China to that in Costa Rica?
Make the answer very short. 28.49. What is the ratio of the Value added (constant 2005 US$) in 1962 in China to that in Costa Rica?
Provide a short and direct response. 23.43. What is the ratio of the Value added (constant 2005 US$) of 1963 in China to that in Costa Rica?
Provide a succinct answer. 24.48. What is the ratio of the Value added (constant 2005 US$) in 1960 in China to that in France?
Offer a very short reply. 0.19. What is the ratio of the Value added (constant 2005 US$) of 1961 in China to that in France?
Offer a very short reply. 0.1. What is the ratio of the Value added (constant 2005 US$) of 1962 in China to that in France?
Your answer should be compact. 0.08. What is the ratio of the Value added (constant 2005 US$) in 1963 in China to that in France?
Your response must be concise. 0.09. What is the ratio of the Value added (constant 2005 US$) in 1960 in Congo (Republic) to that in Costa Rica?
Make the answer very short. 0.66. What is the ratio of the Value added (constant 2005 US$) in 1961 in Congo (Republic) to that in Costa Rica?
Give a very brief answer. 0.76. What is the ratio of the Value added (constant 2005 US$) of 1962 in Congo (Republic) to that in Costa Rica?
Your response must be concise. 0.73. What is the ratio of the Value added (constant 2005 US$) of 1963 in Congo (Republic) to that in Costa Rica?
Keep it short and to the point. 0.64. What is the ratio of the Value added (constant 2005 US$) of 1960 in Congo (Republic) to that in France?
Ensure brevity in your answer.  0. What is the ratio of the Value added (constant 2005 US$) in 1961 in Congo (Republic) to that in France?
Ensure brevity in your answer.  0. What is the ratio of the Value added (constant 2005 US$) in 1962 in Congo (Republic) to that in France?
Your answer should be very brief. 0. What is the ratio of the Value added (constant 2005 US$) in 1963 in Congo (Republic) to that in France?
Offer a very short reply. 0. What is the ratio of the Value added (constant 2005 US$) of 1960 in Costa Rica to that in France?
Your answer should be compact. 0. What is the ratio of the Value added (constant 2005 US$) in 1961 in Costa Rica to that in France?
Ensure brevity in your answer.  0. What is the ratio of the Value added (constant 2005 US$) in 1962 in Costa Rica to that in France?
Provide a succinct answer. 0. What is the ratio of the Value added (constant 2005 US$) of 1963 in Costa Rica to that in France?
Your answer should be very brief. 0. What is the difference between the highest and the second highest Value added (constant 2005 US$) of 1960?
Keep it short and to the point. 8.43e+1. What is the difference between the highest and the second highest Value added (constant 2005 US$) in 1961?
Keep it short and to the point. 1.00e+11. What is the difference between the highest and the second highest Value added (constant 2005 US$) in 1962?
Provide a succinct answer. 1.09e+11. What is the difference between the highest and the second highest Value added (constant 2005 US$) of 1963?
Your answer should be very brief. 1.17e+11. What is the difference between the highest and the lowest Value added (constant 2005 US$) of 1960?
Your answer should be very brief. 1.04e+11. What is the difference between the highest and the lowest Value added (constant 2005 US$) of 1961?
Your response must be concise. 1.12e+11. What is the difference between the highest and the lowest Value added (constant 2005 US$) of 1962?
Your answer should be compact. 1.19e+11. What is the difference between the highest and the lowest Value added (constant 2005 US$) in 1963?
Keep it short and to the point. 1.28e+11. 